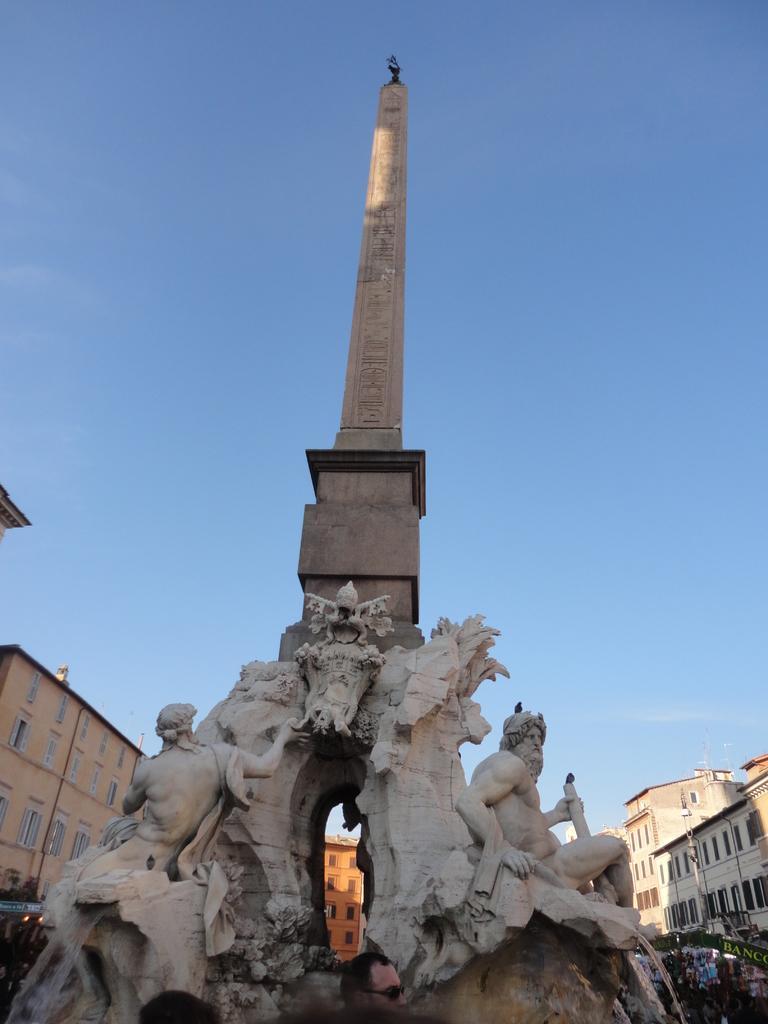Describe this image in one or two sentences. In the center of the image there is a tower. At the bottom we can see sculptures. In the background there are buildings and sky. 